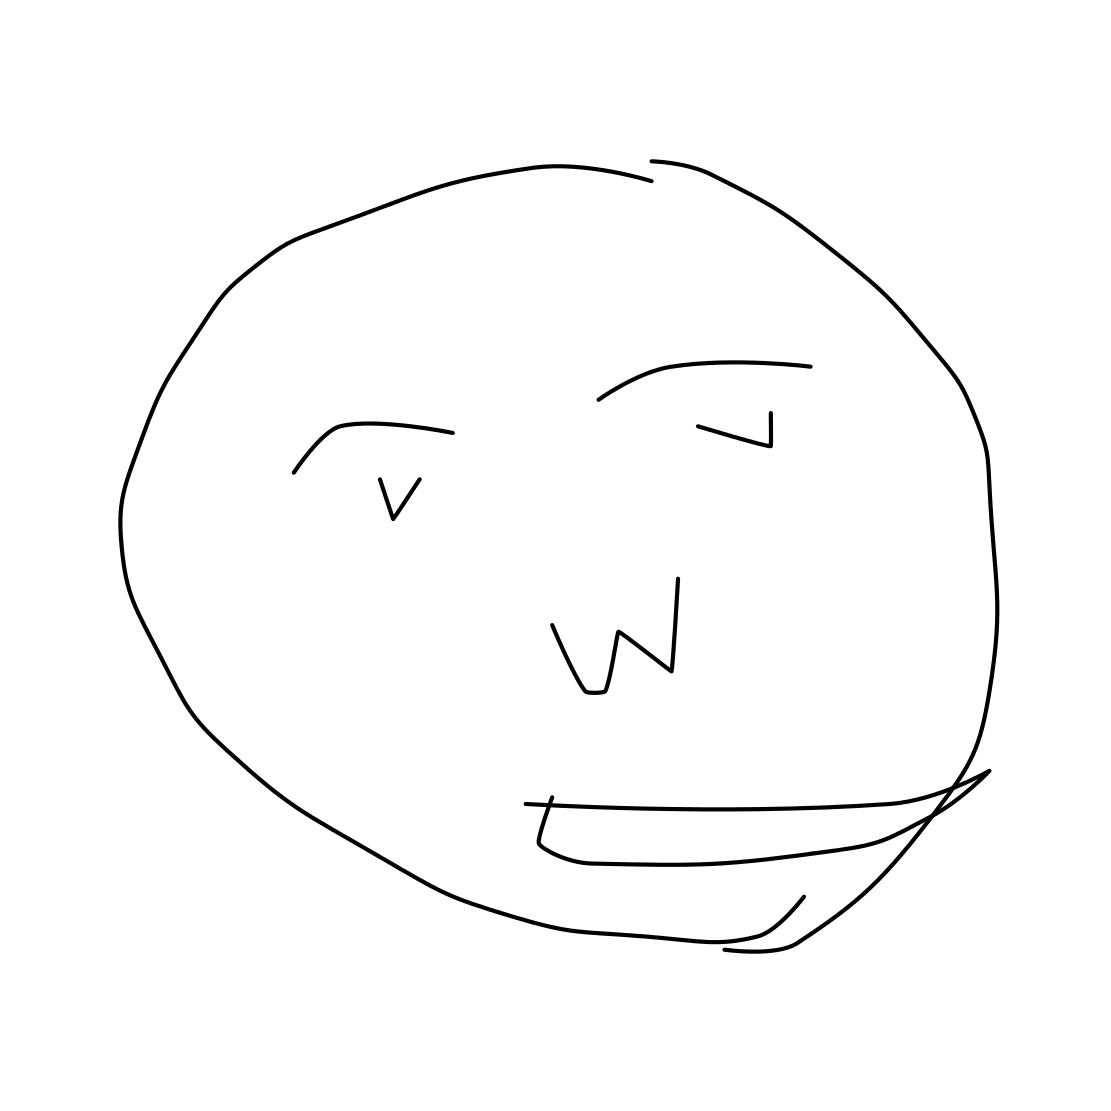Is this a face in the image? Yes, the image does contain a face, depicted with a simple, cartoonish style. It includes basic facial features such as eyes, a mouth, and a general outline of the face shape. 